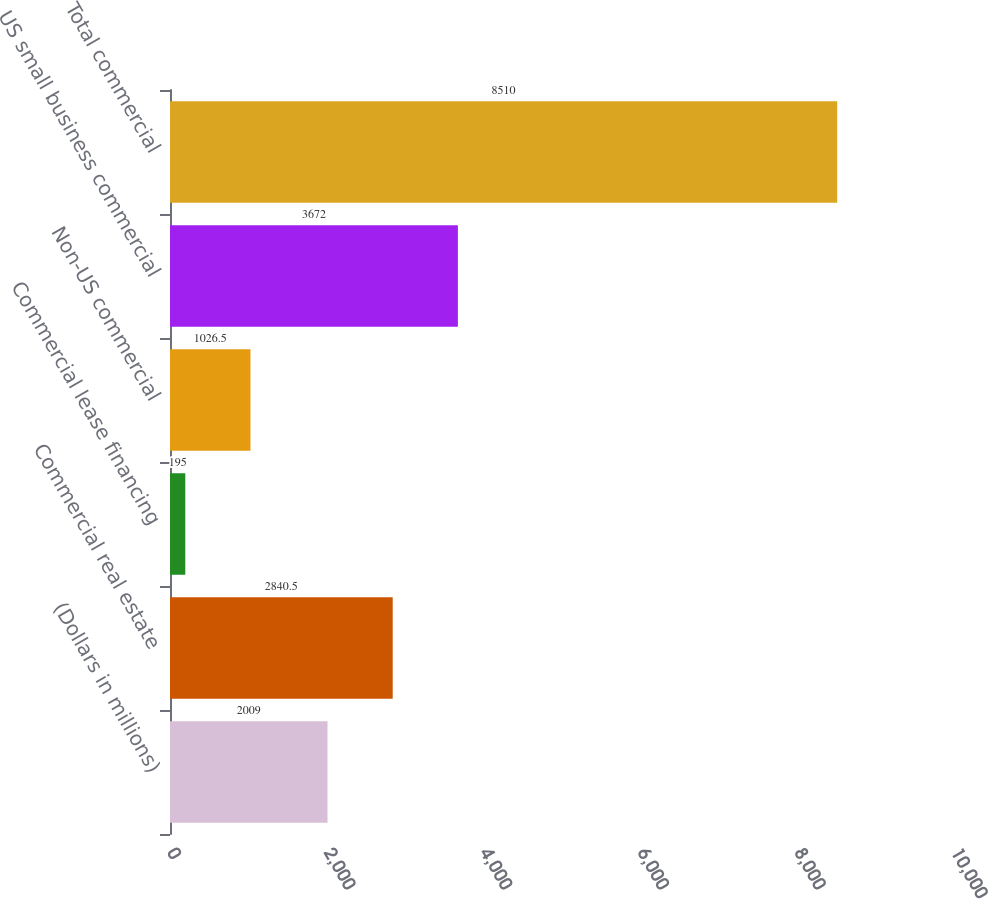Convert chart. <chart><loc_0><loc_0><loc_500><loc_500><bar_chart><fcel>(Dollars in millions)<fcel>Commercial real estate<fcel>Commercial lease financing<fcel>Non-US commercial<fcel>US small business commercial<fcel>Total commercial<nl><fcel>2009<fcel>2840.5<fcel>195<fcel>1026.5<fcel>3672<fcel>8510<nl></chart> 